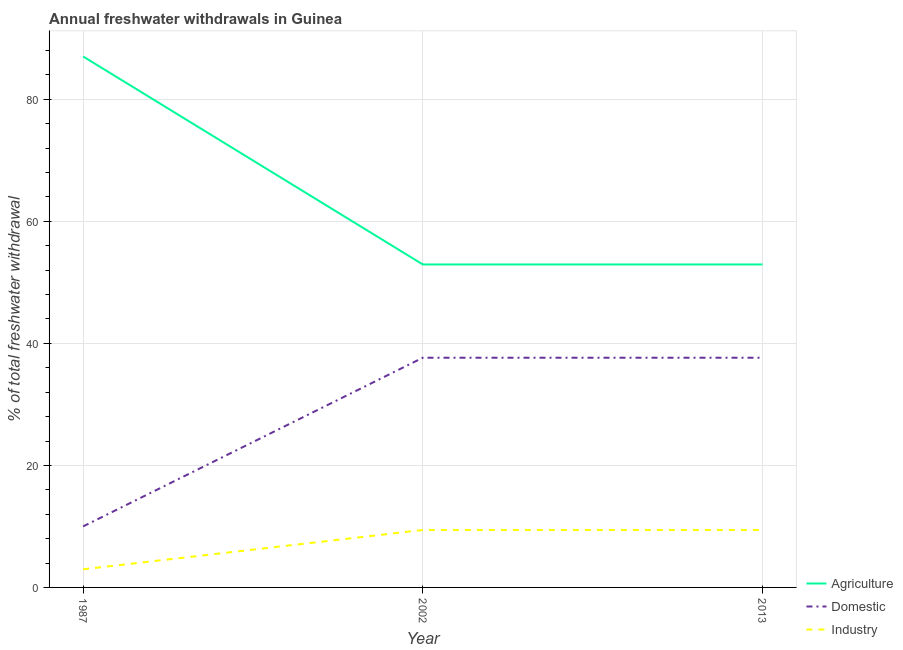How many different coloured lines are there?
Ensure brevity in your answer.  3. Does the line corresponding to percentage of freshwater withdrawal for industry intersect with the line corresponding to percentage of freshwater withdrawal for domestic purposes?
Your answer should be compact. No. What is the percentage of freshwater withdrawal for domestic purposes in 2002?
Provide a short and direct response. 37.65. Across all years, what is the maximum percentage of freshwater withdrawal for domestic purposes?
Make the answer very short. 37.65. Across all years, what is the minimum percentage of freshwater withdrawal for agriculture?
Offer a terse response. 52.94. In which year was the percentage of freshwater withdrawal for industry maximum?
Offer a very short reply. 2002. In which year was the percentage of freshwater withdrawal for agriculture minimum?
Provide a succinct answer. 2002. What is the total percentage of freshwater withdrawal for domestic purposes in the graph?
Give a very brief answer. 85.3. What is the difference between the percentage of freshwater withdrawal for agriculture in 1987 and that in 2002?
Your answer should be very brief. 34.09. What is the difference between the percentage of freshwater withdrawal for domestic purposes in 2013 and the percentage of freshwater withdrawal for industry in 1987?
Make the answer very short. 34.68. What is the average percentage of freshwater withdrawal for domestic purposes per year?
Offer a terse response. 28.43. In the year 2013, what is the difference between the percentage of freshwater withdrawal for agriculture and percentage of freshwater withdrawal for domestic purposes?
Your answer should be very brief. 15.29. In how many years, is the percentage of freshwater withdrawal for industry greater than 76 %?
Offer a very short reply. 0. What is the ratio of the percentage of freshwater withdrawal for domestic purposes in 1987 to that in 2002?
Your answer should be very brief. 0.27. What is the difference between the highest and the second highest percentage of freshwater withdrawal for domestic purposes?
Offer a very short reply. 0. What is the difference between the highest and the lowest percentage of freshwater withdrawal for agriculture?
Provide a short and direct response. 34.09. In how many years, is the percentage of freshwater withdrawal for domestic purposes greater than the average percentage of freshwater withdrawal for domestic purposes taken over all years?
Your answer should be compact. 2. Does the percentage of freshwater withdrawal for agriculture monotonically increase over the years?
Give a very brief answer. No. Is the percentage of freshwater withdrawal for agriculture strictly less than the percentage of freshwater withdrawal for domestic purposes over the years?
Keep it short and to the point. No. How many lines are there?
Offer a terse response. 3. How many years are there in the graph?
Make the answer very short. 3. What is the difference between two consecutive major ticks on the Y-axis?
Keep it short and to the point. 20. Are the values on the major ticks of Y-axis written in scientific E-notation?
Provide a succinct answer. No. Does the graph contain any zero values?
Provide a short and direct response. No. Where does the legend appear in the graph?
Your response must be concise. Bottom right. How are the legend labels stacked?
Offer a very short reply. Vertical. What is the title of the graph?
Your answer should be very brief. Annual freshwater withdrawals in Guinea. What is the label or title of the Y-axis?
Ensure brevity in your answer.  % of total freshwater withdrawal. What is the % of total freshwater withdrawal in Agriculture in 1987?
Ensure brevity in your answer.  87.03. What is the % of total freshwater withdrawal of Industry in 1987?
Make the answer very short. 2.97. What is the % of total freshwater withdrawal in Agriculture in 2002?
Offer a terse response. 52.94. What is the % of total freshwater withdrawal in Domestic in 2002?
Offer a very short reply. 37.65. What is the % of total freshwater withdrawal of Industry in 2002?
Give a very brief answer. 9.42. What is the % of total freshwater withdrawal of Agriculture in 2013?
Provide a succinct answer. 52.94. What is the % of total freshwater withdrawal of Domestic in 2013?
Give a very brief answer. 37.65. What is the % of total freshwater withdrawal in Industry in 2013?
Provide a short and direct response. 9.42. Across all years, what is the maximum % of total freshwater withdrawal of Agriculture?
Offer a very short reply. 87.03. Across all years, what is the maximum % of total freshwater withdrawal of Domestic?
Keep it short and to the point. 37.65. Across all years, what is the maximum % of total freshwater withdrawal of Industry?
Offer a terse response. 9.42. Across all years, what is the minimum % of total freshwater withdrawal of Agriculture?
Your answer should be very brief. 52.94. Across all years, what is the minimum % of total freshwater withdrawal in Industry?
Ensure brevity in your answer.  2.97. What is the total % of total freshwater withdrawal in Agriculture in the graph?
Make the answer very short. 192.91. What is the total % of total freshwater withdrawal in Domestic in the graph?
Provide a short and direct response. 85.3. What is the total % of total freshwater withdrawal of Industry in the graph?
Offer a terse response. 21.8. What is the difference between the % of total freshwater withdrawal of Agriculture in 1987 and that in 2002?
Ensure brevity in your answer.  34.09. What is the difference between the % of total freshwater withdrawal in Domestic in 1987 and that in 2002?
Offer a very short reply. -27.65. What is the difference between the % of total freshwater withdrawal of Industry in 1987 and that in 2002?
Your response must be concise. -6.44. What is the difference between the % of total freshwater withdrawal in Agriculture in 1987 and that in 2013?
Your answer should be compact. 34.09. What is the difference between the % of total freshwater withdrawal in Domestic in 1987 and that in 2013?
Offer a very short reply. -27.65. What is the difference between the % of total freshwater withdrawal of Industry in 1987 and that in 2013?
Provide a succinct answer. -6.44. What is the difference between the % of total freshwater withdrawal in Agriculture in 2002 and that in 2013?
Provide a succinct answer. 0. What is the difference between the % of total freshwater withdrawal of Agriculture in 1987 and the % of total freshwater withdrawal of Domestic in 2002?
Provide a short and direct response. 49.38. What is the difference between the % of total freshwater withdrawal of Agriculture in 1987 and the % of total freshwater withdrawal of Industry in 2002?
Ensure brevity in your answer.  77.61. What is the difference between the % of total freshwater withdrawal in Domestic in 1987 and the % of total freshwater withdrawal in Industry in 2002?
Ensure brevity in your answer.  0.58. What is the difference between the % of total freshwater withdrawal in Agriculture in 1987 and the % of total freshwater withdrawal in Domestic in 2013?
Keep it short and to the point. 49.38. What is the difference between the % of total freshwater withdrawal in Agriculture in 1987 and the % of total freshwater withdrawal in Industry in 2013?
Offer a terse response. 77.61. What is the difference between the % of total freshwater withdrawal in Domestic in 1987 and the % of total freshwater withdrawal in Industry in 2013?
Ensure brevity in your answer.  0.58. What is the difference between the % of total freshwater withdrawal of Agriculture in 2002 and the % of total freshwater withdrawal of Domestic in 2013?
Your response must be concise. 15.29. What is the difference between the % of total freshwater withdrawal of Agriculture in 2002 and the % of total freshwater withdrawal of Industry in 2013?
Offer a very short reply. 43.52. What is the difference between the % of total freshwater withdrawal of Domestic in 2002 and the % of total freshwater withdrawal of Industry in 2013?
Your response must be concise. 28.23. What is the average % of total freshwater withdrawal in Agriculture per year?
Your answer should be very brief. 64.3. What is the average % of total freshwater withdrawal of Domestic per year?
Give a very brief answer. 28.43. What is the average % of total freshwater withdrawal in Industry per year?
Offer a very short reply. 7.27. In the year 1987, what is the difference between the % of total freshwater withdrawal of Agriculture and % of total freshwater withdrawal of Domestic?
Make the answer very short. 77.03. In the year 1987, what is the difference between the % of total freshwater withdrawal in Agriculture and % of total freshwater withdrawal in Industry?
Provide a short and direct response. 84.06. In the year 1987, what is the difference between the % of total freshwater withdrawal in Domestic and % of total freshwater withdrawal in Industry?
Offer a very short reply. 7.03. In the year 2002, what is the difference between the % of total freshwater withdrawal in Agriculture and % of total freshwater withdrawal in Domestic?
Ensure brevity in your answer.  15.29. In the year 2002, what is the difference between the % of total freshwater withdrawal of Agriculture and % of total freshwater withdrawal of Industry?
Give a very brief answer. 43.52. In the year 2002, what is the difference between the % of total freshwater withdrawal in Domestic and % of total freshwater withdrawal in Industry?
Your answer should be very brief. 28.23. In the year 2013, what is the difference between the % of total freshwater withdrawal of Agriculture and % of total freshwater withdrawal of Domestic?
Your response must be concise. 15.29. In the year 2013, what is the difference between the % of total freshwater withdrawal of Agriculture and % of total freshwater withdrawal of Industry?
Your response must be concise. 43.52. In the year 2013, what is the difference between the % of total freshwater withdrawal in Domestic and % of total freshwater withdrawal in Industry?
Provide a short and direct response. 28.23. What is the ratio of the % of total freshwater withdrawal in Agriculture in 1987 to that in 2002?
Provide a short and direct response. 1.64. What is the ratio of the % of total freshwater withdrawal in Domestic in 1987 to that in 2002?
Offer a very short reply. 0.27. What is the ratio of the % of total freshwater withdrawal in Industry in 1987 to that in 2002?
Provide a short and direct response. 0.32. What is the ratio of the % of total freshwater withdrawal of Agriculture in 1987 to that in 2013?
Ensure brevity in your answer.  1.64. What is the ratio of the % of total freshwater withdrawal in Domestic in 1987 to that in 2013?
Make the answer very short. 0.27. What is the ratio of the % of total freshwater withdrawal of Industry in 1987 to that in 2013?
Give a very brief answer. 0.32. What is the ratio of the % of total freshwater withdrawal of Industry in 2002 to that in 2013?
Give a very brief answer. 1. What is the difference between the highest and the second highest % of total freshwater withdrawal of Agriculture?
Offer a very short reply. 34.09. What is the difference between the highest and the lowest % of total freshwater withdrawal in Agriculture?
Provide a short and direct response. 34.09. What is the difference between the highest and the lowest % of total freshwater withdrawal in Domestic?
Your answer should be very brief. 27.65. What is the difference between the highest and the lowest % of total freshwater withdrawal in Industry?
Offer a very short reply. 6.44. 